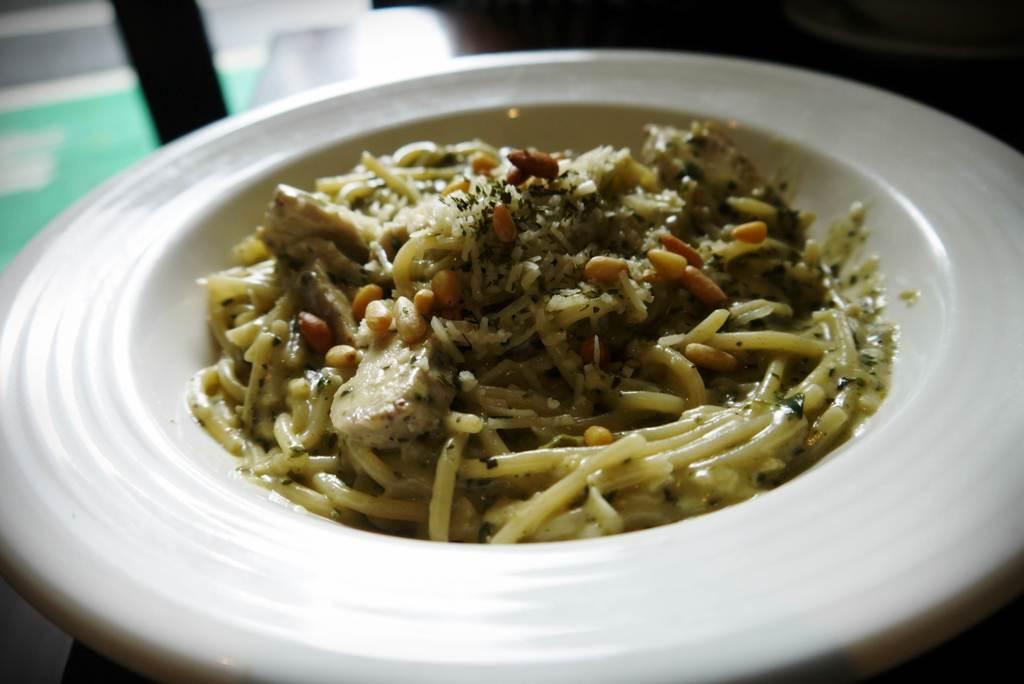Could you give a brief overview of what you see in this image? The picture consists of a dish, served in a plate. At the top it is blurred. 